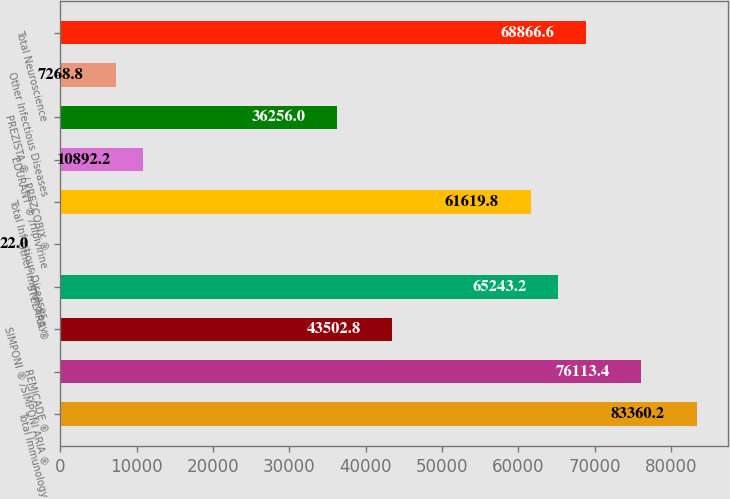Convert chart to OTSL. <chart><loc_0><loc_0><loc_500><loc_500><bar_chart><fcel>Total Immunology<fcel>REMICADE ®<fcel>SIMPONI ® /SIMPONI ARIA ®<fcel>STELARA ®<fcel>Other Immunology<fcel>Total Infectious Diseases<fcel>EDURANT ® /rilpivirine<fcel>PREZISTA ® / PREZCOBIX ®<fcel>Other Infectious Diseases<fcel>Total Neuroscience<nl><fcel>83360.2<fcel>76113.4<fcel>43502.8<fcel>65243.2<fcel>22<fcel>61619.8<fcel>10892.2<fcel>36256<fcel>7268.8<fcel>68866.6<nl></chart> 